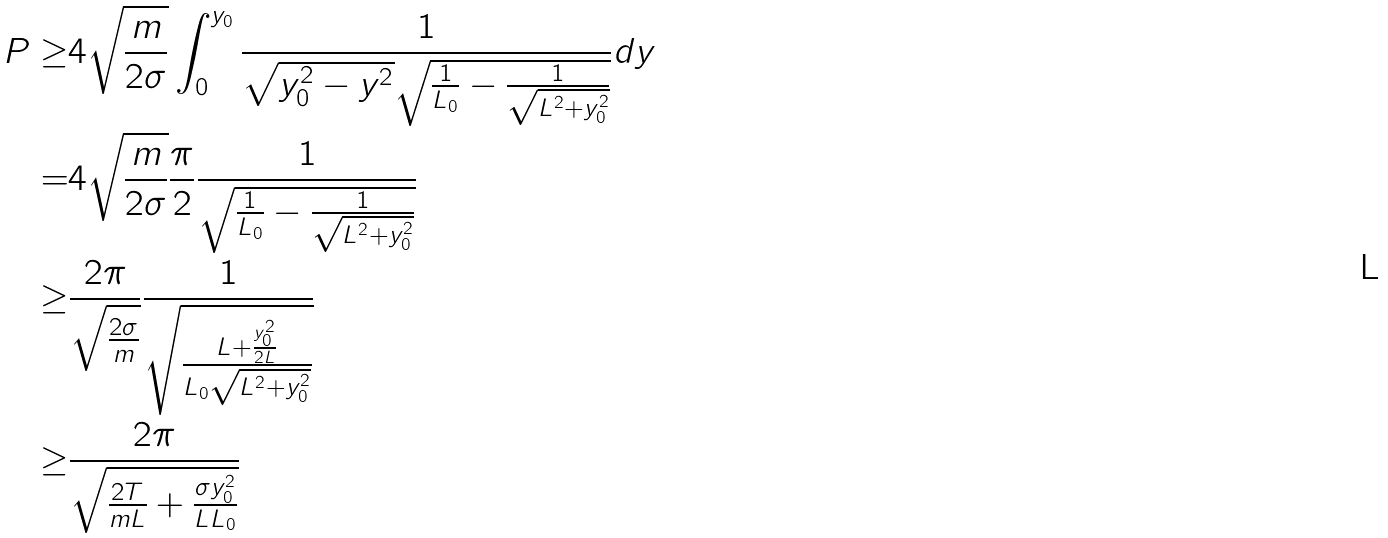<formula> <loc_0><loc_0><loc_500><loc_500>P \geq & 4 \sqrt { \frac { m } { 2 \sigma } } \int _ { 0 } ^ { y _ { 0 } } \frac { 1 } { \sqrt { y _ { 0 } ^ { 2 } - y ^ { 2 } } \sqrt { \frac { 1 } { L _ { 0 } } - \frac { 1 } { \sqrt { L ^ { 2 } + y _ { 0 } ^ { 2 } } } } } d y \\ = & 4 \sqrt { \frac { m } { 2 \sigma } } \frac { \pi } { 2 } \frac { 1 } { \sqrt { \frac { 1 } { L _ { 0 } } - \frac { 1 } { \sqrt { L ^ { 2 } + y _ { 0 } ^ { 2 } } } } } \\ \geq & \frac { 2 \pi } { \sqrt { \frac { 2 \sigma } { m } } } \frac { 1 } { \sqrt { \frac { L + \frac { y _ { 0 } ^ { 2 } } { 2 L } } { L _ { 0 } \sqrt { L ^ { 2 } + y _ { 0 } ^ { 2 } } } } } \\ \geq & \frac { 2 \pi } { \sqrt { \frac { 2 T } { m L } + \frac { \sigma y _ { 0 } ^ { 2 } } { L L _ { 0 } } } }</formula> 